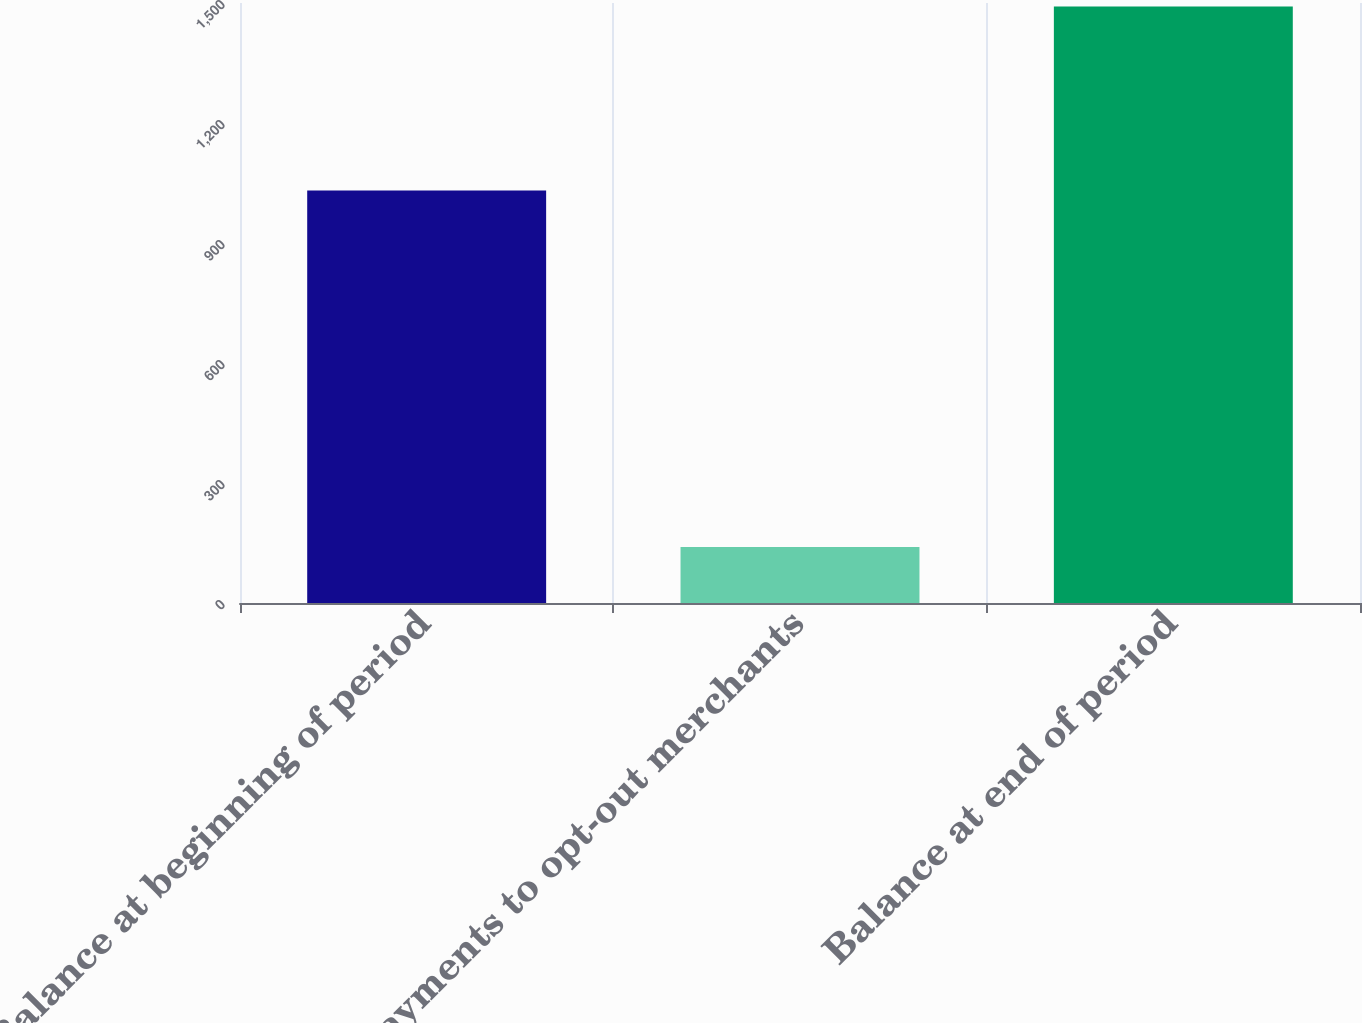<chart> <loc_0><loc_0><loc_500><loc_500><bar_chart><fcel>Balance at beginning of period<fcel>Payments to opt-out merchants<fcel>Balance at end of period<nl><fcel>1031<fcel>140<fcel>1491<nl></chart> 